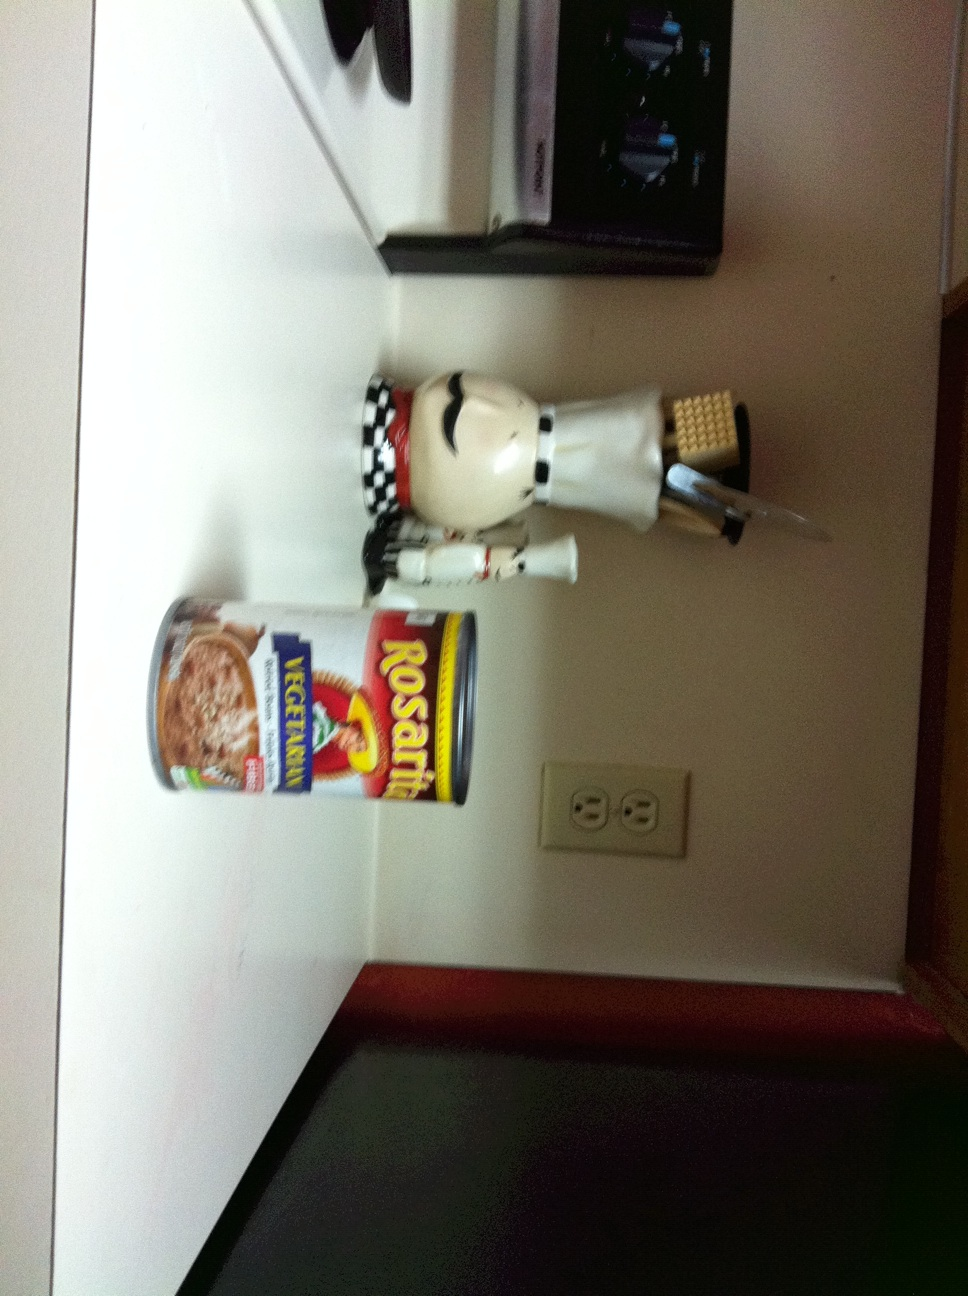What does the setting of the image suggest about its location? The setting appears to be a household kitchen, indicated by typical kitchen elements such as a knife block, electrical outlets, and countertops. The presence of kitchen appliances and decor suggests a domestic environment. Is there anything interesting about the way objects are placed? Yes, the placement of the ice cream can directly on the countertop and the decorative statuette positioned adjacently adds a casual, homely feel to the setting. It seems like a snapshot of everyday kitchen scenery with personal touches. 